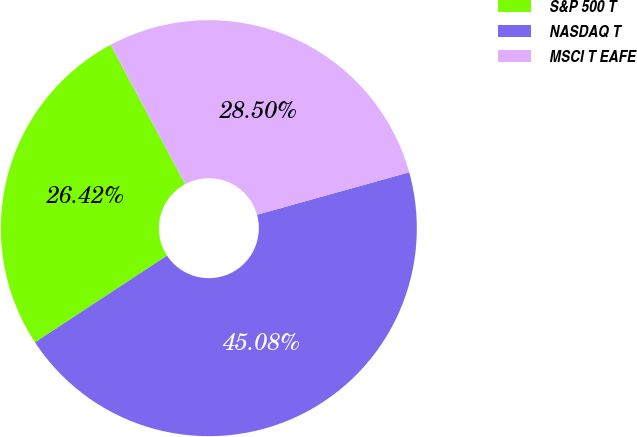Convert chart. <chart><loc_0><loc_0><loc_500><loc_500><pie_chart><fcel>S&P 500 T<fcel>NASDAQ T<fcel>MSCI T EAFE<nl><fcel>26.42%<fcel>45.08%<fcel>28.5%<nl></chart> 